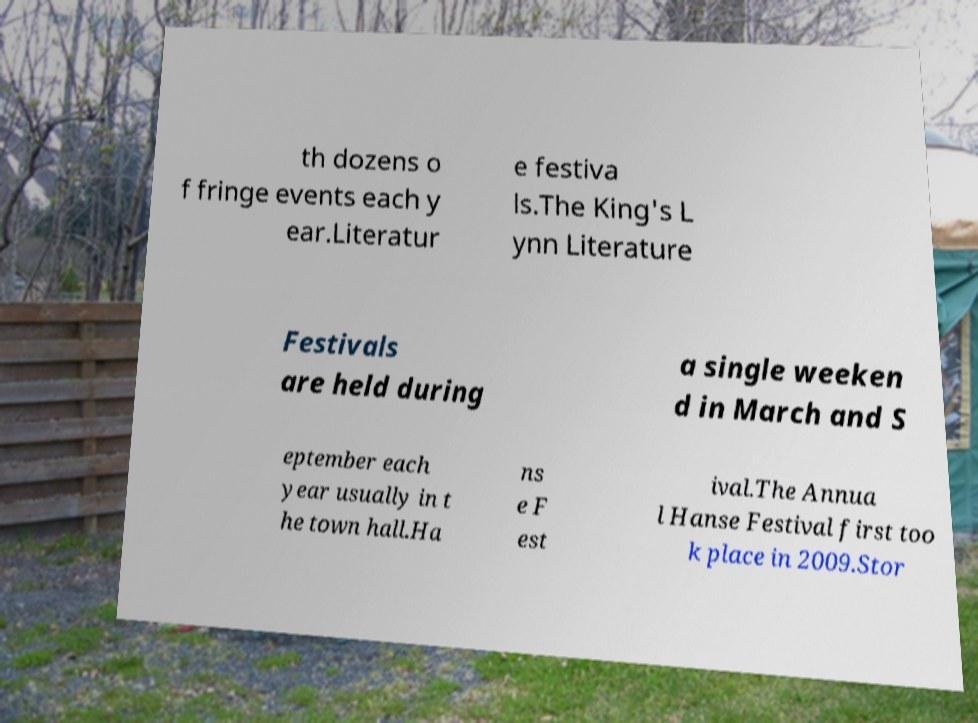Please read and relay the text visible in this image. What does it say? th dozens o f fringe events each y ear.Literatur e festiva ls.The King's L ynn Literature Festivals are held during a single weeken d in March and S eptember each year usually in t he town hall.Ha ns e F est ival.The Annua l Hanse Festival first too k place in 2009.Stor 